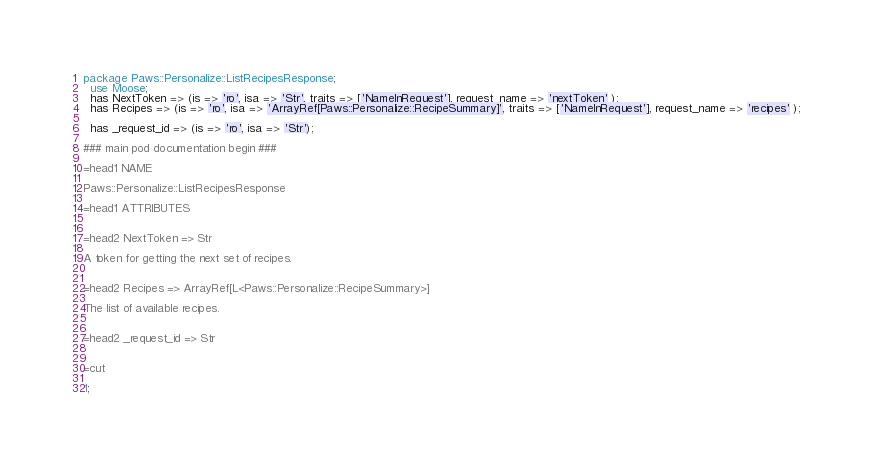Convert code to text. <code><loc_0><loc_0><loc_500><loc_500><_Perl_>
package Paws::Personalize::ListRecipesResponse;
  use Moose;
  has NextToken => (is => 'ro', isa => 'Str', traits => ['NameInRequest'], request_name => 'nextToken' );
  has Recipes => (is => 'ro', isa => 'ArrayRef[Paws::Personalize::RecipeSummary]', traits => ['NameInRequest'], request_name => 'recipes' );

  has _request_id => (is => 'ro', isa => 'Str');

### main pod documentation begin ###

=head1 NAME

Paws::Personalize::ListRecipesResponse

=head1 ATTRIBUTES


=head2 NextToken => Str

A token for getting the next set of recipes.


=head2 Recipes => ArrayRef[L<Paws::Personalize::RecipeSummary>]

The list of available recipes.


=head2 _request_id => Str


=cut

1;</code> 